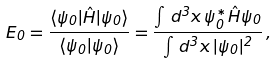Convert formula to latex. <formula><loc_0><loc_0><loc_500><loc_500>E _ { 0 } = \frac { \langle \psi _ { 0 } | \hat { H } | \psi _ { 0 } \rangle } { \langle \psi _ { 0 } | \psi _ { 0 } \rangle } = \frac { \int \, d ^ { 3 } x \, \psi _ { 0 } ^ { * } \hat { H } \psi _ { 0 } } { \int \, d ^ { 3 } x \, | \psi _ { 0 } | ^ { 2 } } \, ,</formula> 